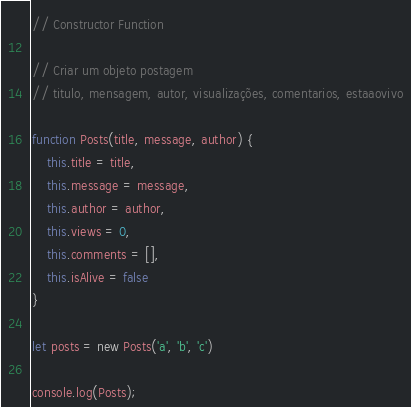Convert code to text. <code><loc_0><loc_0><loc_500><loc_500><_JavaScript_>// Constructor Function

// Criar um objeto postagem
// titulo, mensagem, autor, visualizações, comentarios, estaaovivo

function Posts(title, message, author) {
    this.title = title,
    this.message = message,
    this.author = author,
    this.views = 0,
    this.comments = [],
    this.isAlive = false
}

let posts = new Posts('a', 'b', 'c')

console.log(Posts);</code> 